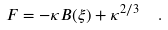Convert formula to latex. <formula><loc_0><loc_0><loc_500><loc_500>F = - \kappa B ( \xi ) + \kappa ^ { 2 / 3 } \ \ .</formula> 